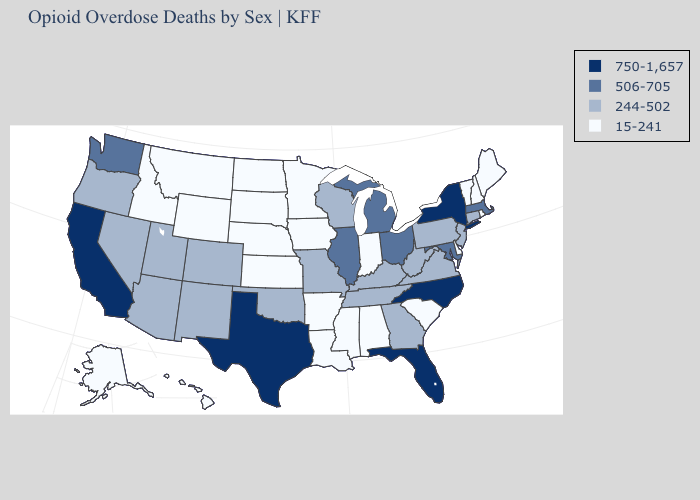Which states hav the highest value in the West?
Quick response, please. California. Name the states that have a value in the range 750-1,657?
Be succinct. California, Florida, New York, North Carolina, Texas. How many symbols are there in the legend?
Quick response, please. 4. Among the states that border Illinois , which have the lowest value?
Quick response, please. Indiana, Iowa. What is the lowest value in states that border Idaho?
Keep it brief. 15-241. Name the states that have a value in the range 244-502?
Write a very short answer. Arizona, Colorado, Connecticut, Georgia, Kentucky, Missouri, Nevada, New Jersey, New Mexico, Oklahoma, Oregon, Pennsylvania, Tennessee, Utah, Virginia, West Virginia, Wisconsin. Name the states that have a value in the range 244-502?
Quick response, please. Arizona, Colorado, Connecticut, Georgia, Kentucky, Missouri, Nevada, New Jersey, New Mexico, Oklahoma, Oregon, Pennsylvania, Tennessee, Utah, Virginia, West Virginia, Wisconsin. What is the highest value in the USA?
Quick response, please. 750-1,657. Which states have the highest value in the USA?
Answer briefly. California, Florida, New York, North Carolina, Texas. Name the states that have a value in the range 506-705?
Keep it brief. Illinois, Maryland, Massachusetts, Michigan, Ohio, Washington. What is the value of Nevada?
Give a very brief answer. 244-502. Does Georgia have the lowest value in the USA?
Quick response, please. No. Which states have the highest value in the USA?
Be succinct. California, Florida, New York, North Carolina, Texas. What is the value of Minnesota?
Quick response, please. 15-241. 